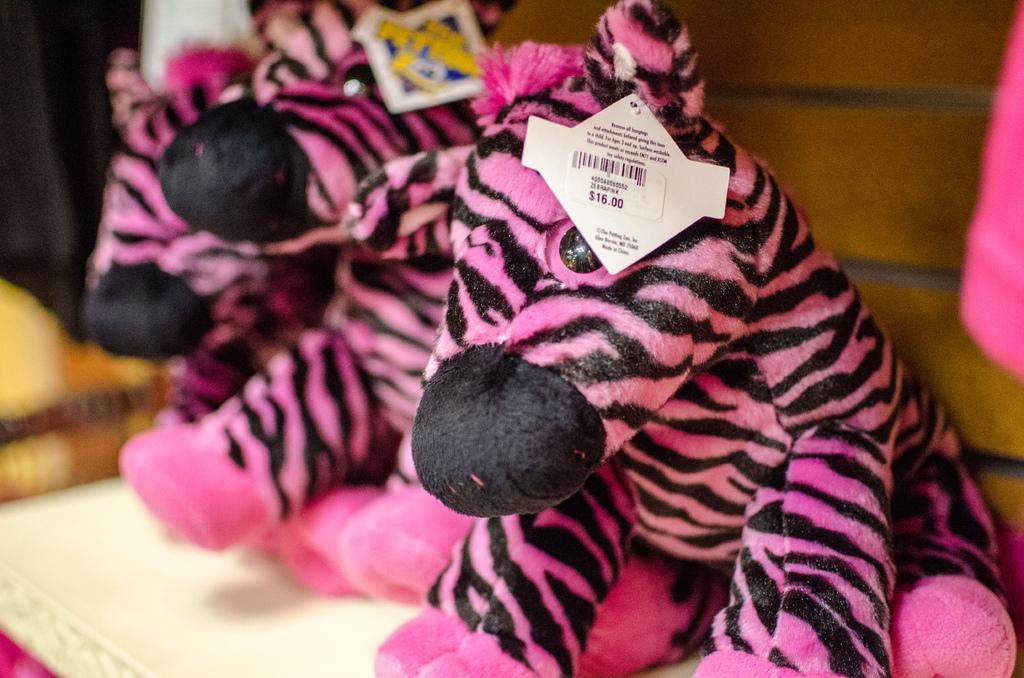What is placed on the shelves in the image? There are dollars on the shelves in the image. How are the dollars organized or labeled? The dollars have price tags. What other items can be seen in the image? There are dolls in the image. What is visible behind the dolls? There is a wall behind the dolls. What type of wren can be seen perched on the wall behind the dolls? There is no wren present in the image; it only features dollars on shelves, dolls, and a wall. What scent is emanating from the dolls in the image? There is no mention of a scent in the image, as it only focuses on the visual elements of the scene. 